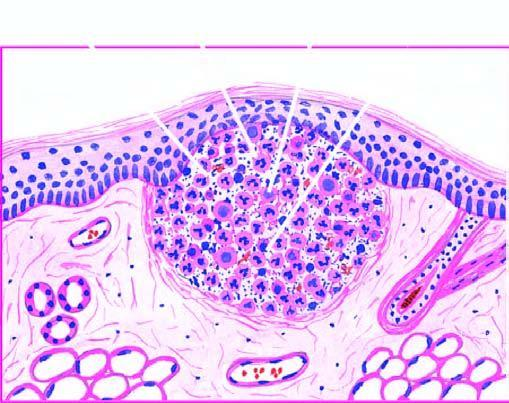re the alveolar spaces as well as interstitium seen at the periphery?
Answer the question using a single word or phrase. No 